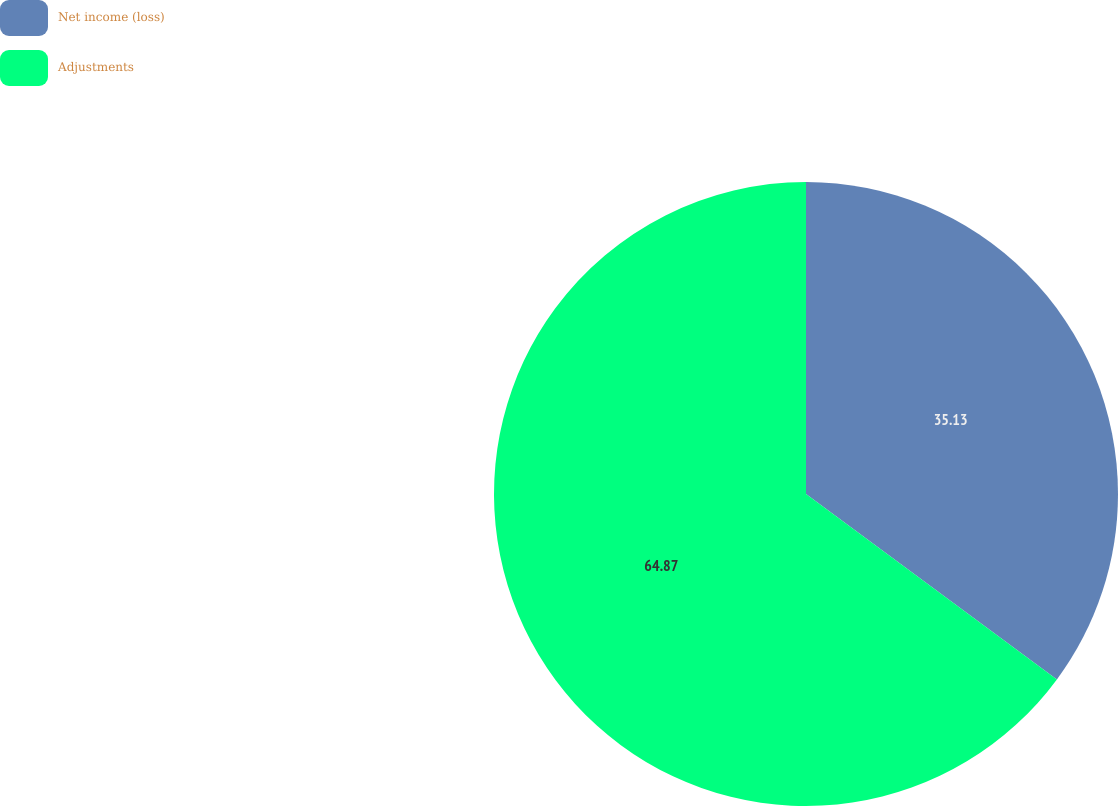<chart> <loc_0><loc_0><loc_500><loc_500><pie_chart><fcel>Net income (loss)<fcel>Adjustments<nl><fcel>35.13%<fcel>64.87%<nl></chart> 